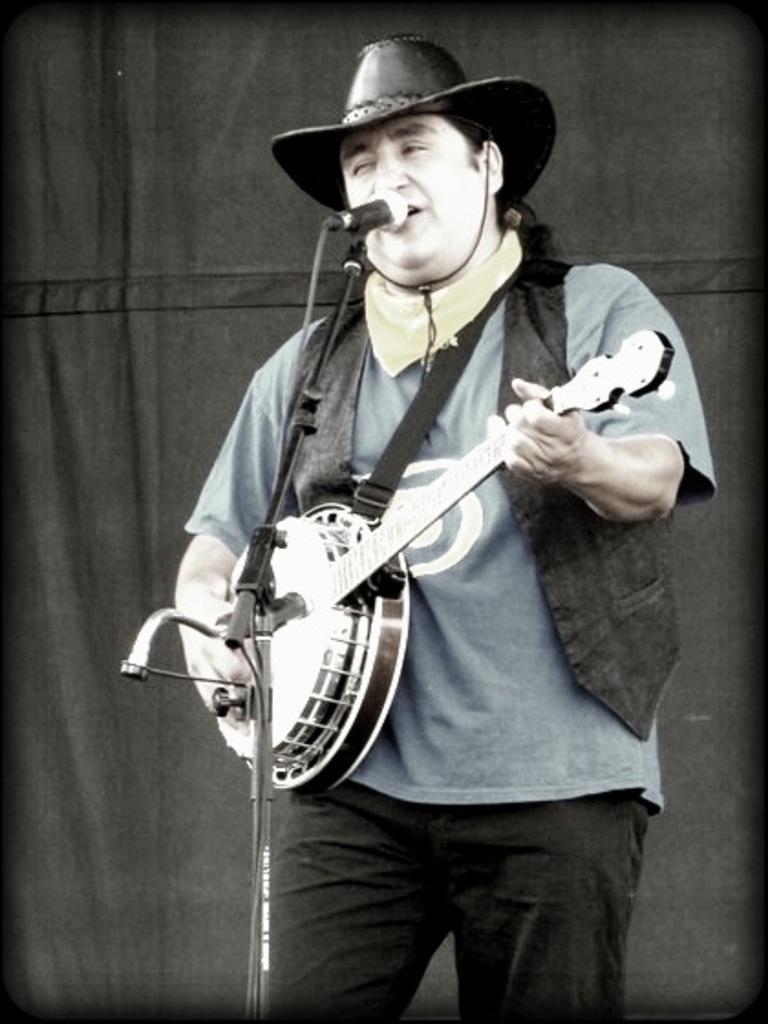Can you describe this image briefly? This image is taken outdoors. In the background there is a cloth. In the middle of the image a man is standing and he is holding a musical instrument in his hands. He is singing and there's a mic. He has worn a hat, a coat and a pant. 